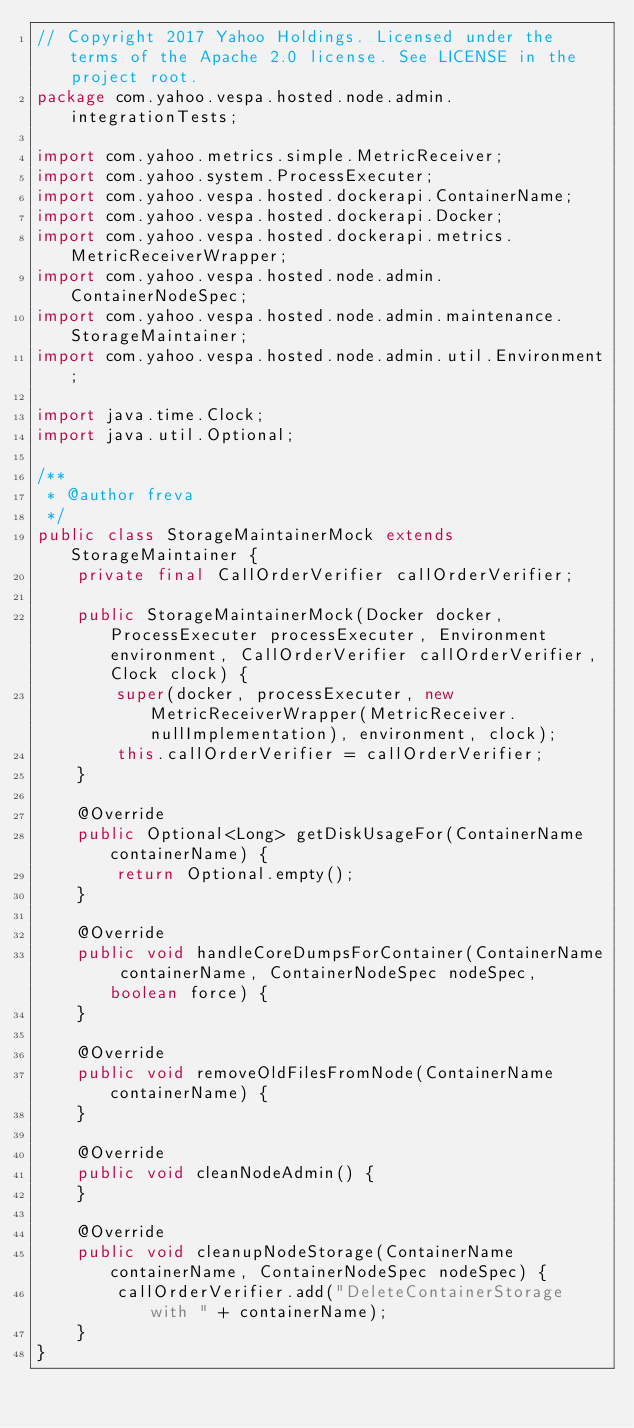Convert code to text. <code><loc_0><loc_0><loc_500><loc_500><_Java_>// Copyright 2017 Yahoo Holdings. Licensed under the terms of the Apache 2.0 license. See LICENSE in the project root.
package com.yahoo.vespa.hosted.node.admin.integrationTests;

import com.yahoo.metrics.simple.MetricReceiver;
import com.yahoo.system.ProcessExecuter;
import com.yahoo.vespa.hosted.dockerapi.ContainerName;
import com.yahoo.vespa.hosted.dockerapi.Docker;
import com.yahoo.vespa.hosted.dockerapi.metrics.MetricReceiverWrapper;
import com.yahoo.vespa.hosted.node.admin.ContainerNodeSpec;
import com.yahoo.vespa.hosted.node.admin.maintenance.StorageMaintainer;
import com.yahoo.vespa.hosted.node.admin.util.Environment;

import java.time.Clock;
import java.util.Optional;

/**
 * @author freva
 */
public class StorageMaintainerMock extends StorageMaintainer {
    private final CallOrderVerifier callOrderVerifier;

    public StorageMaintainerMock(Docker docker, ProcessExecuter processExecuter, Environment environment, CallOrderVerifier callOrderVerifier, Clock clock) {
        super(docker, processExecuter, new MetricReceiverWrapper(MetricReceiver.nullImplementation), environment, clock);
        this.callOrderVerifier = callOrderVerifier;
    }

    @Override
    public Optional<Long> getDiskUsageFor(ContainerName containerName) {
        return Optional.empty();
    }

    @Override
    public void handleCoreDumpsForContainer(ContainerName containerName, ContainerNodeSpec nodeSpec, boolean force) {
    }

    @Override
    public void removeOldFilesFromNode(ContainerName containerName) {
    }

    @Override
    public void cleanNodeAdmin() {
    }

    @Override
    public void cleanupNodeStorage(ContainerName containerName, ContainerNodeSpec nodeSpec) {
        callOrderVerifier.add("DeleteContainerStorage with " + containerName);
    }
}
</code> 